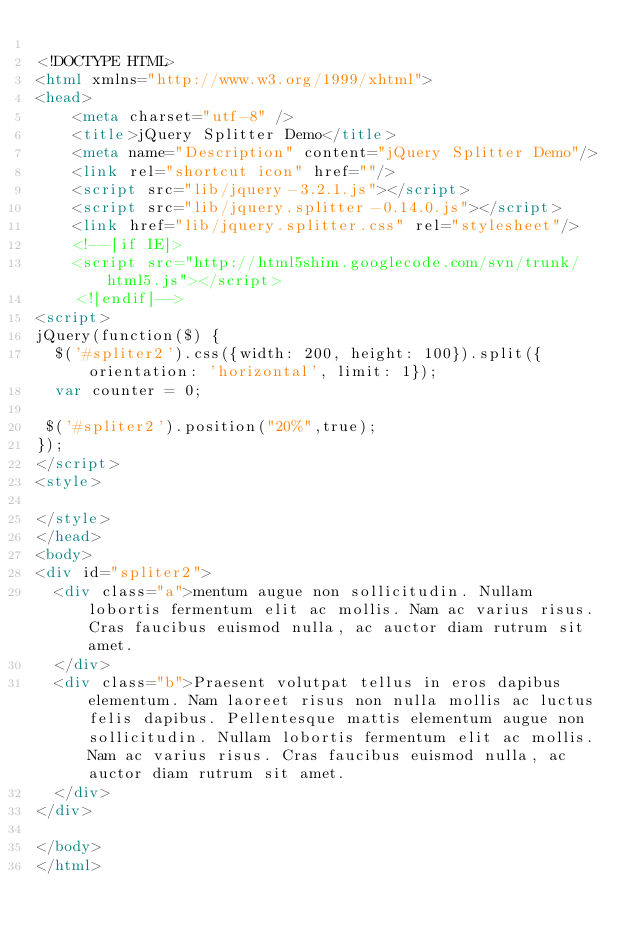Convert code to text. <code><loc_0><loc_0><loc_500><loc_500><_HTML_>
<!DOCTYPE HTML>
<html xmlns="http://www.w3.org/1999/xhtml">
<head>
    <meta charset="utf-8" />
    <title>jQuery Splitter Demo</title>
    <meta name="Description" content="jQuery Splitter Demo"/>
    <link rel="shortcut icon" href=""/>
    <script src="lib/jquery-3.2.1.js"></script>
    <script src="lib/jquery.splitter-0.14.0.js"></script>
    <link href="lib/jquery.splitter.css" rel="stylesheet"/>
    <!--[if IE]>
    <script src="http://html5shim.googlecode.com/svn/trunk/html5.js"></script>
    <![endif]-->
<script>
jQuery(function($) {
  $('#spliter2').css({width: 200, height: 100}).split({orientation: 'horizontal', limit: 1});
  var counter = 0;

 $('#spliter2').position("20%",true);
});
</script>
<style>

</style>
</head>
<body>
<div id="spliter2">
  <div class="a">mentum augue non sollicitudin. Nullam lobortis fermentum elit ac mollis. Nam ac varius risus. Cras faucibus euismod nulla, ac auctor diam rutrum sit amet.
  </div>
  <div class="b">Praesent volutpat tellus in eros dapibus elementum. Nam laoreet risus non nulla mollis ac luctus felis dapibus. Pellentesque mattis elementum augue non sollicitudin. Nullam lobortis fermentum elit ac mollis. Nam ac varius risus. Cras faucibus euismod nulla, ac auctor diam rutrum sit amet.
  </div>
</div>

</body>
</html>
</code> 